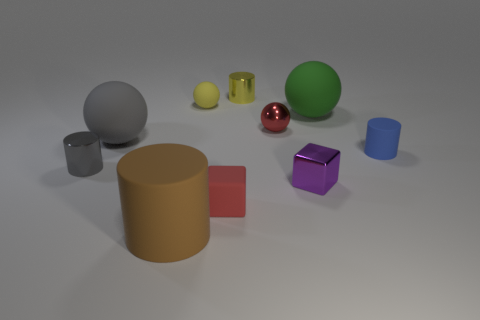How many other things are the same color as the large rubber cylinder?
Your answer should be compact. 0. Does the metal thing on the left side of the brown thing have the same size as the red matte cube?
Offer a terse response. Yes. Are there any yellow rubber balls of the same size as the brown cylinder?
Keep it short and to the point. No. There is a small object left of the tiny yellow ball; what color is it?
Keep it short and to the point. Gray. There is a tiny matte object that is both to the left of the green rubber ball and to the right of the tiny matte sphere; what shape is it?
Offer a terse response. Cube. How many large green metallic things are the same shape as the tiny red matte thing?
Your answer should be compact. 0. How many big yellow metallic cylinders are there?
Your answer should be very brief. 0. There is a rubber thing that is right of the tiny yellow matte thing and in front of the small purple metal cube; what size is it?
Provide a succinct answer. Small. The purple thing that is the same size as the red matte thing is what shape?
Provide a short and direct response. Cube. Are there any tiny yellow matte objects that are in front of the rubber sphere in front of the tiny red shiny thing?
Offer a very short reply. No. 